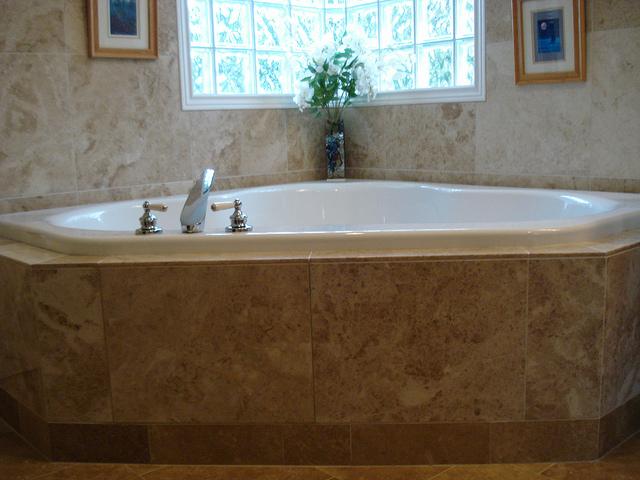How many pictures are on the wall?
Concise answer only. 2. Does the window have a shade on it?
Keep it brief. No. Is there sunlight coming in?
Short answer required. Yes. Is there a curtain on the window?
Be succinct. No. 